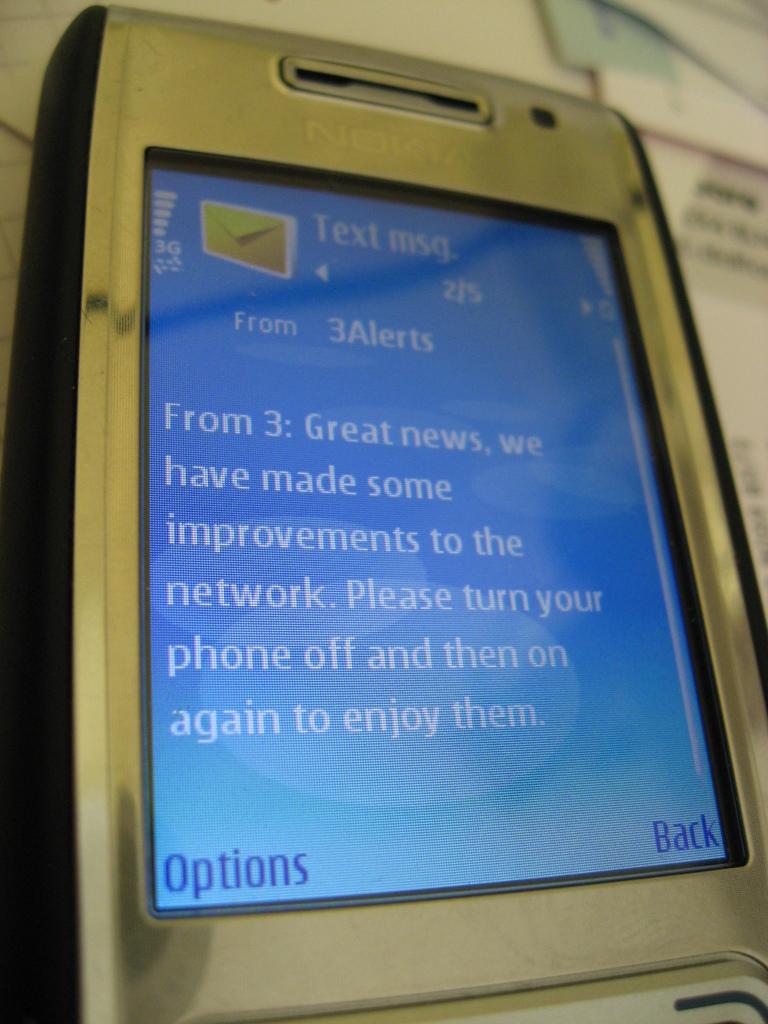What does the text want me to do?
Keep it short and to the point. Turn phone off and on again. What is on the bottom left?
Provide a short and direct response. Options. 